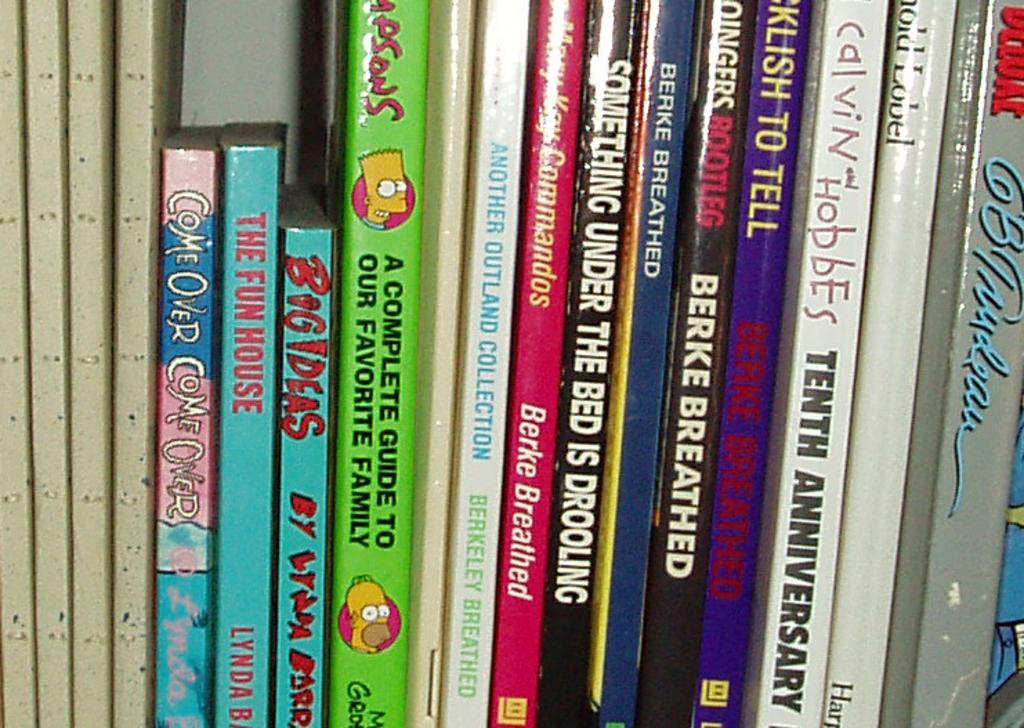Provide a one-sentence caption for the provided image. Books next to one another with one saying "The Fun House". 